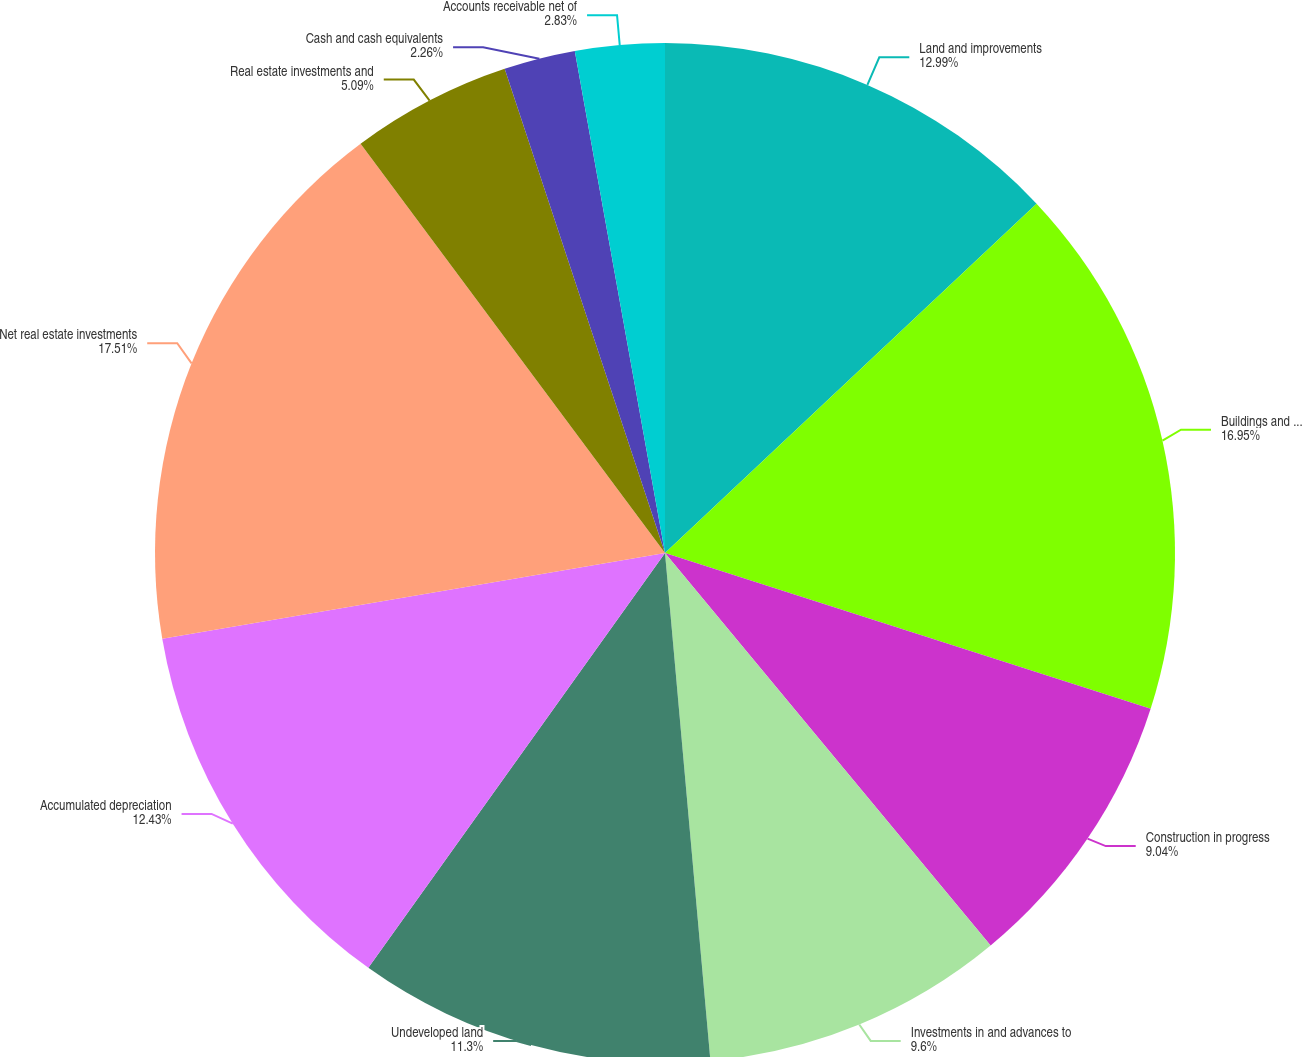Convert chart to OTSL. <chart><loc_0><loc_0><loc_500><loc_500><pie_chart><fcel>Land and improvements<fcel>Buildings and tenant<fcel>Construction in progress<fcel>Investments in and advances to<fcel>Undeveloped land<fcel>Accumulated depreciation<fcel>Net real estate investments<fcel>Real estate investments and<fcel>Cash and cash equivalents<fcel>Accounts receivable net of<nl><fcel>12.99%<fcel>16.95%<fcel>9.04%<fcel>9.6%<fcel>11.3%<fcel>12.43%<fcel>17.51%<fcel>5.09%<fcel>2.26%<fcel>2.83%<nl></chart> 